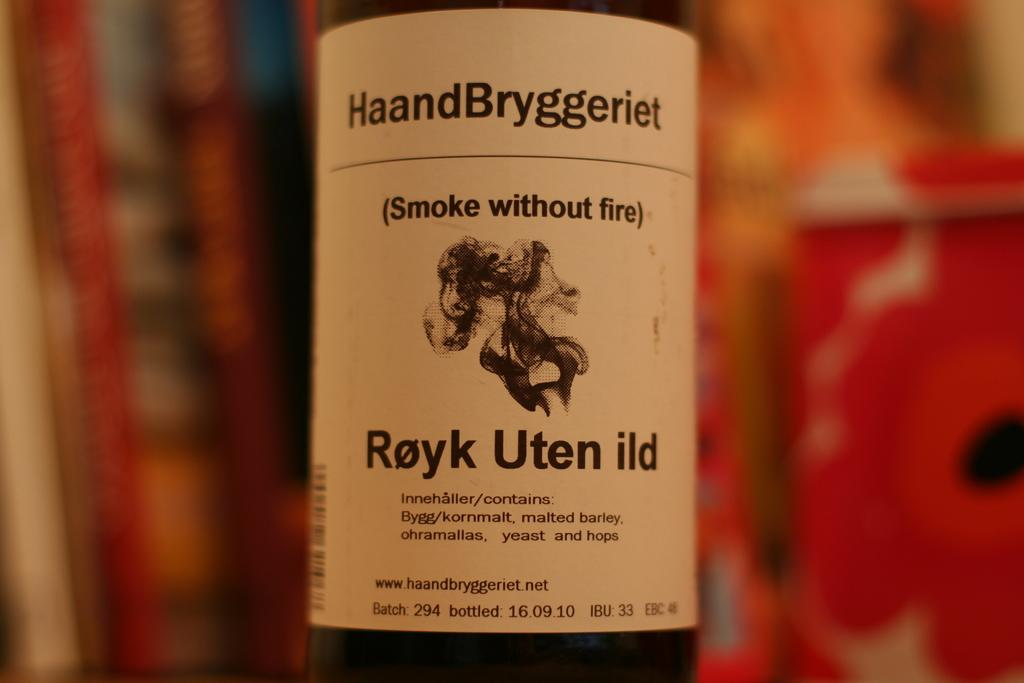<image>
Present a compact description of the photo's key features. A bottle has a HaandBryggeriet label with batch number 294. 